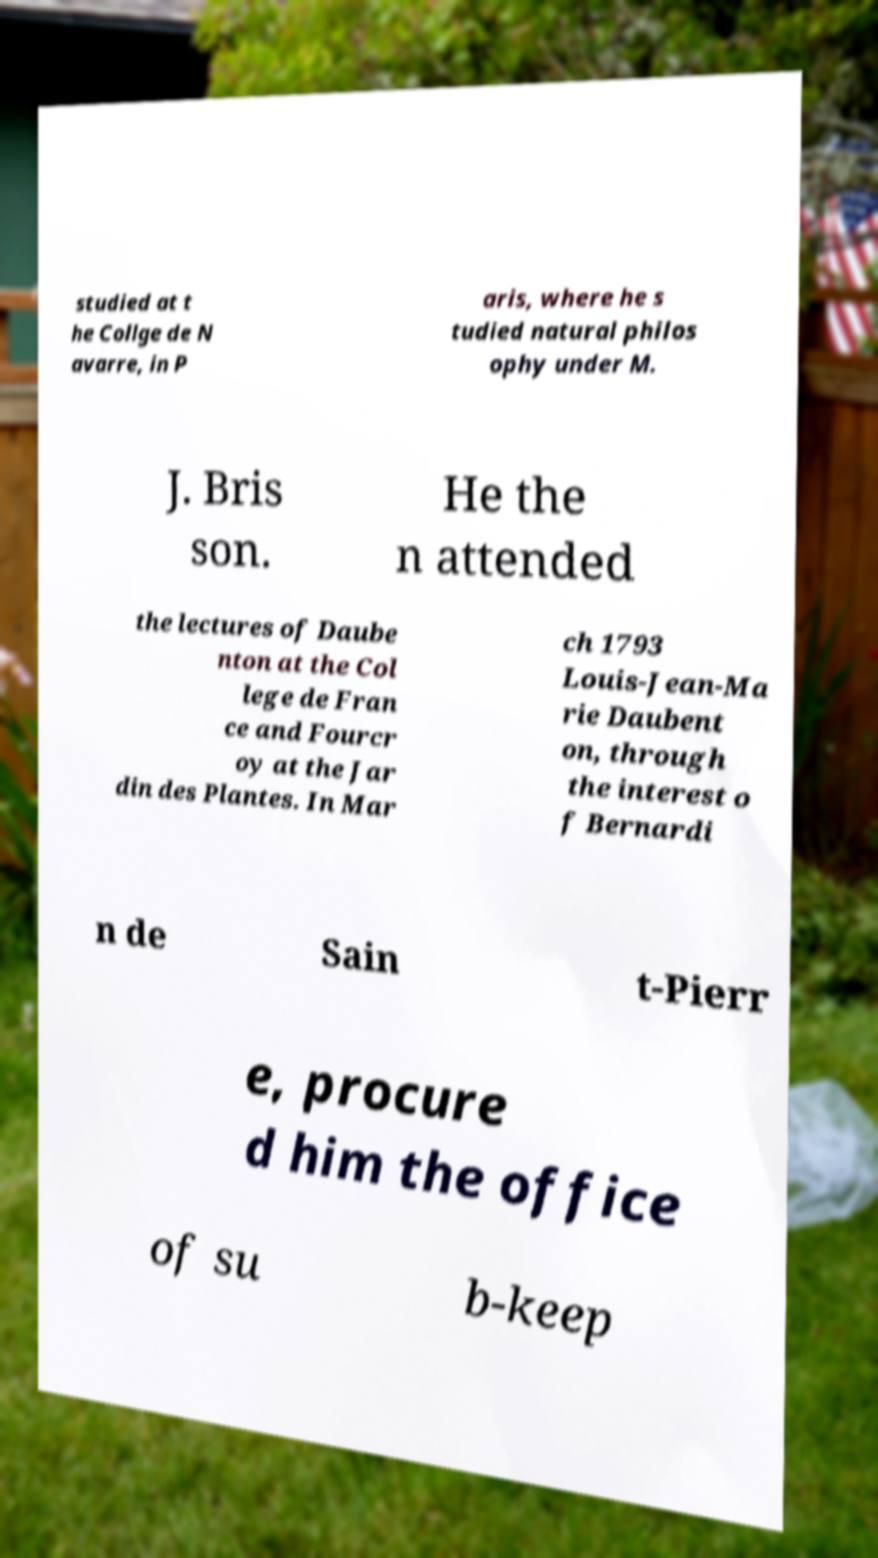Can you read and provide the text displayed in the image?This photo seems to have some interesting text. Can you extract and type it out for me? studied at t he Collge de N avarre, in P aris, where he s tudied natural philos ophy under M. J. Bris son. He the n attended the lectures of Daube nton at the Col lege de Fran ce and Fourcr oy at the Jar din des Plantes. In Mar ch 1793 Louis-Jean-Ma rie Daubent on, through the interest o f Bernardi n de Sain t-Pierr e, procure d him the office of su b-keep 